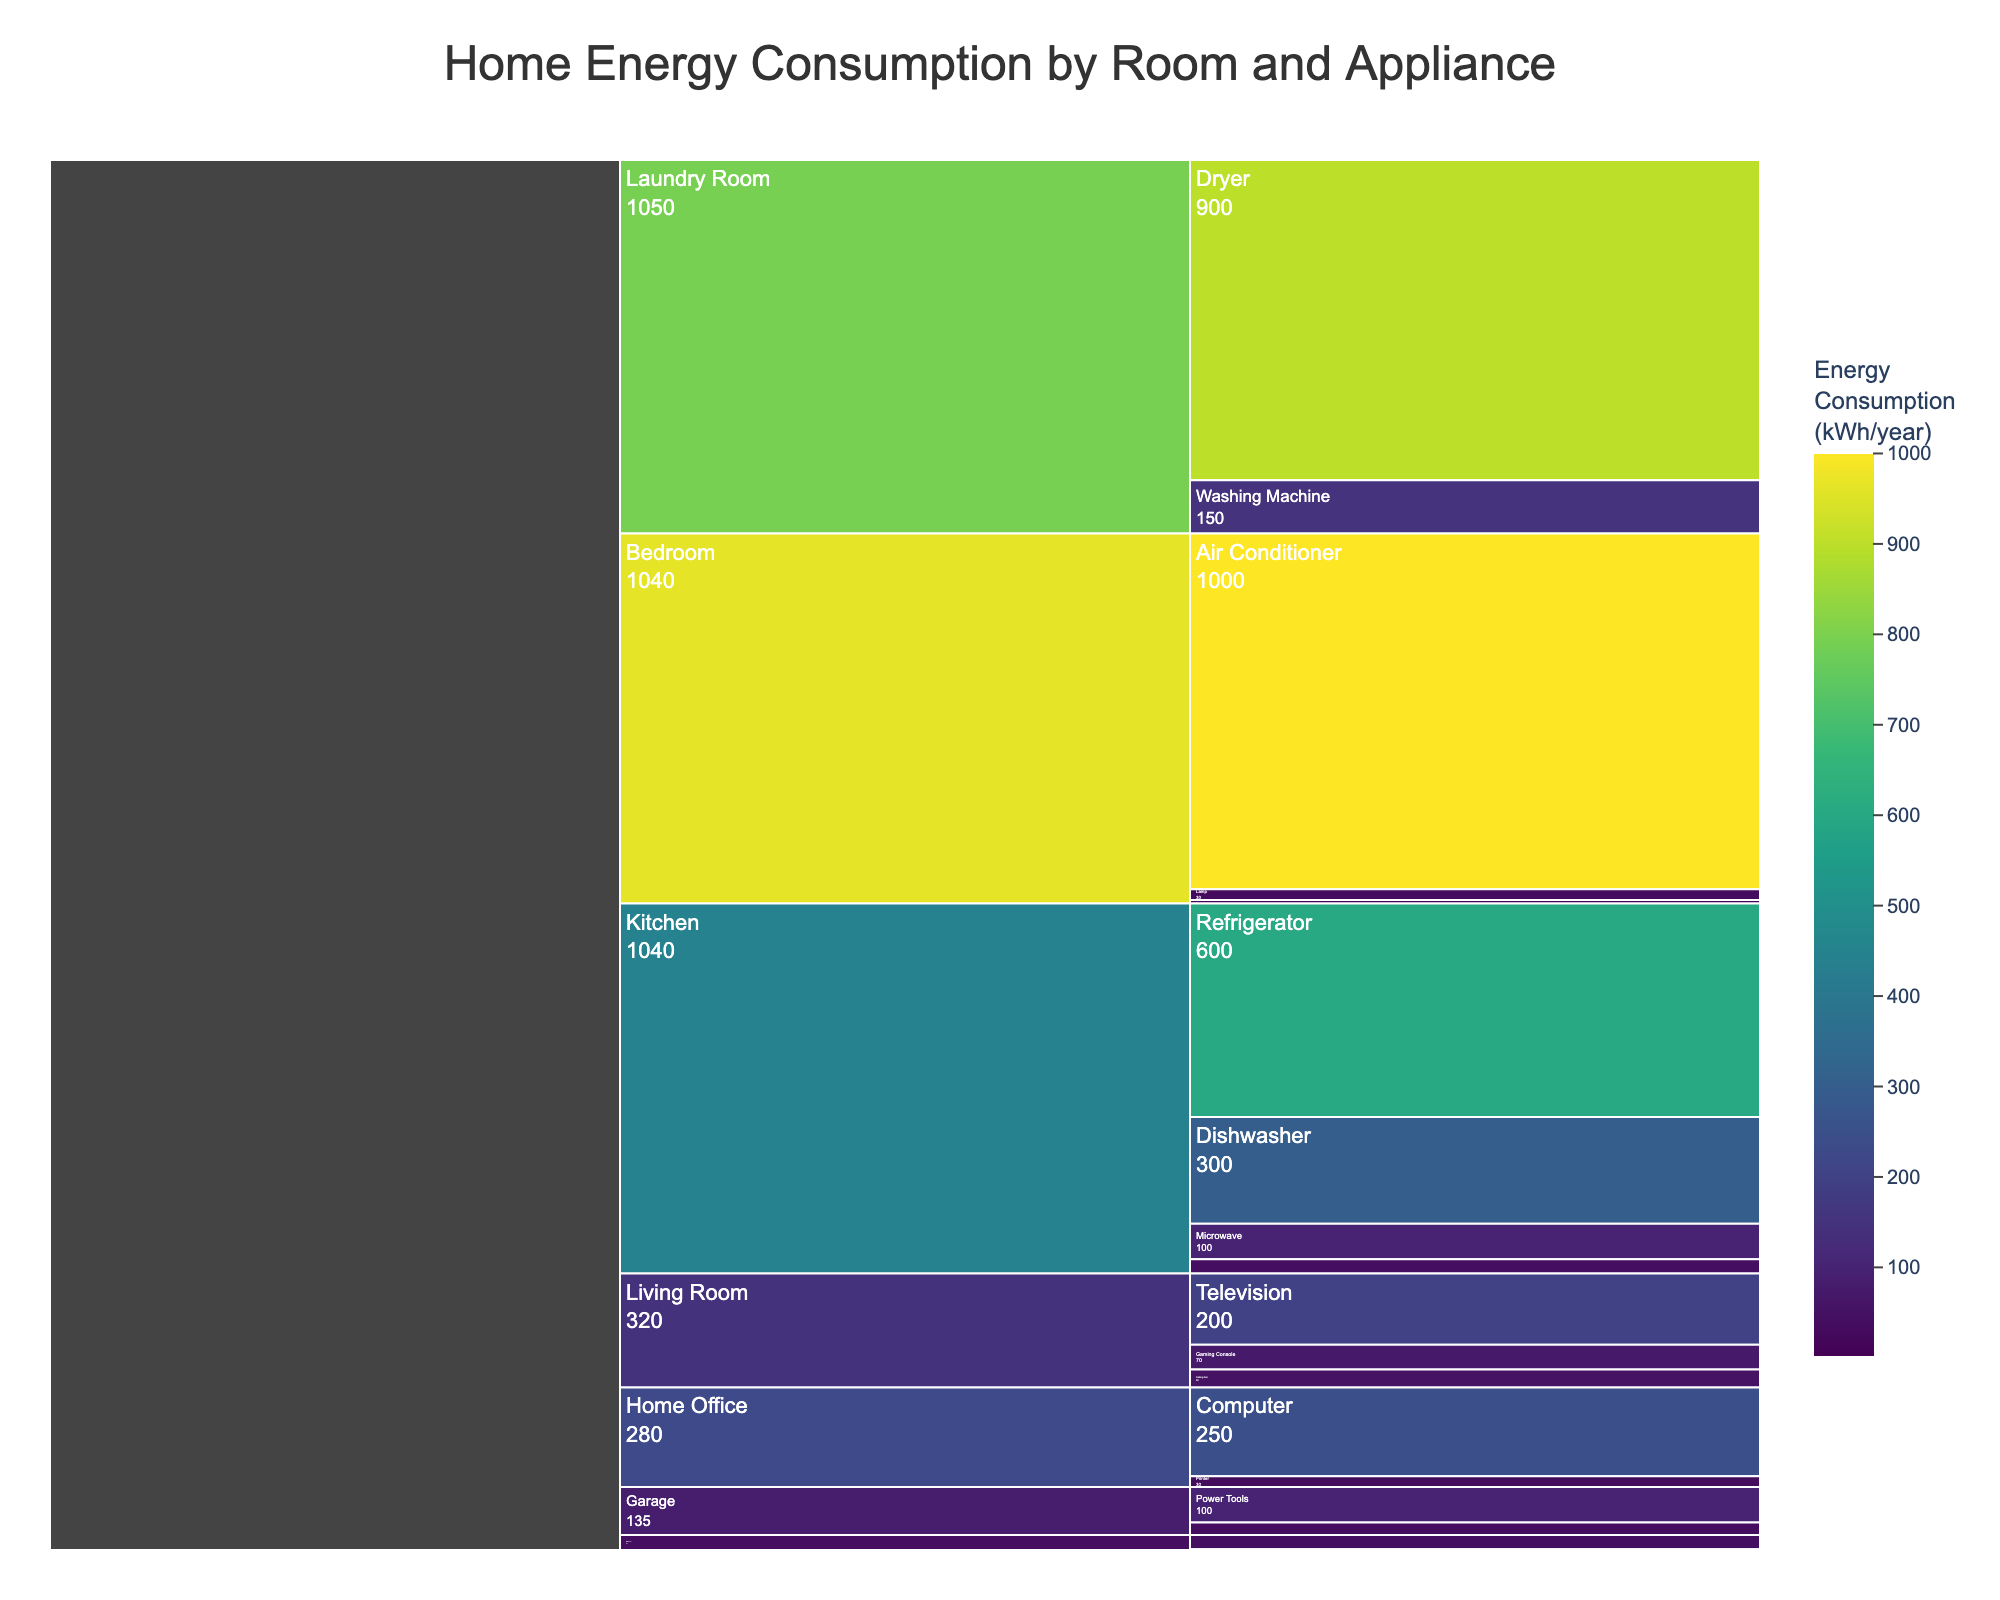what is the total energy consumption of appliances in the Kitchen? Sum the energy consumption values for all kitchen appliances: Refrigerator (600) + Dishwasher (300) + Microwave (100) + Coffee Maker (40) = 1040 kWh/year.
Answer: 1040 kWh/year Which room has the highest energy consumption? The Bedroom, which includes high-consuming appliances like the Air Conditioner (1000 kWh/year) and Lamp (30 kWh/year), totals 1030 kWh/year, surpassing other rooms.
Answer: Bedroom Which appliance consumes the most energy in the Laundry Room? The Dryer consumes 900 kWh/year and is the highest energy-consuming appliance in the Laundry Room compared to the Washing Machine at 150 kWh/year.
Answer: Dryer Compare the energy consumption of the Living Room and Home Office. Which consumes more? Summing the Living Room appliance consumption values: Television (200) + Gaming Console (70) + Ceiling Fan (50) = 320 kWh/year. For the Home Office: Computer (250) + Printer (30) = 280 kWh/year. The Living Room consumes more energy.
Answer: Living Room What is the energy consumption difference between the Refrigerator and the Air Conditioner? Subtract the energy consumption of the Refrigerator (600 kWh/year) from the Air Conditioner (1000 kWh/year): 1000 - 600 = 400 kWh/year.
Answer: 400 kWh/year What is the average energy consumption of appliances in the Garage? Sum the energy consumption values for the Garage appliances: Power Tools (100) + Garage Door Opener (35) = 135 kWh/year. There are 2 appliances, so the average is 135 / 2 = 67.5 kWh/year.
Answer: 67.5 kWh/year Which room has the least energy-consuming appliance, and what is it? The Electric Toothbrush in the Bathroom consumes 2 kWh/year, making it the least energy-consuming appliance among all rooms.
Answer: Bathroom What is the average energy consumption for all appliances in the Home Office? Sum the energy consumption values for Home Office appliances: Computer (250) + Printer (30) = 280 kWh/year. There are 2 appliances, so the average is 280 / 2 = 140 kWh/year.
Answer: 140 kWh/year Which has higher energy consumption: the Television in the Living Room or the Computer in the Home Office? The Television consumes 200 kWh/year, while the Computer consumes 250 kWh/year, so the Computer has higher energy consumption.
Answer: Computer 